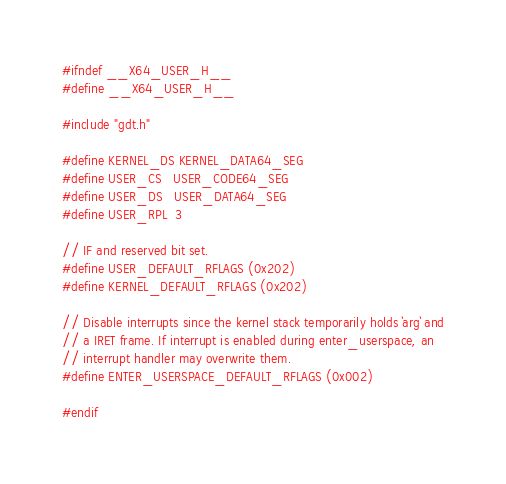<code> <loc_0><loc_0><loc_500><loc_500><_C_>#ifndef __X64_USER_H__
#define __X64_USER_H__

#include "gdt.h"

#define KERNEL_DS KERNEL_DATA64_SEG
#define USER_CS   USER_CODE64_SEG
#define USER_DS   USER_DATA64_SEG
#define USER_RPL  3

// IF and reserved bit set.
#define USER_DEFAULT_RFLAGS (0x202)
#define KERNEL_DEFAULT_RFLAGS (0x202)

// Disable interrupts since the kernel stack temporarily holds `arg` and
// a IRET frame. If interrupt is enabled during enter_userspace, an
// interrupt handler may overwrite them.
#define ENTER_USERSPACE_DEFAULT_RFLAGS (0x002)

#endif
</code> 